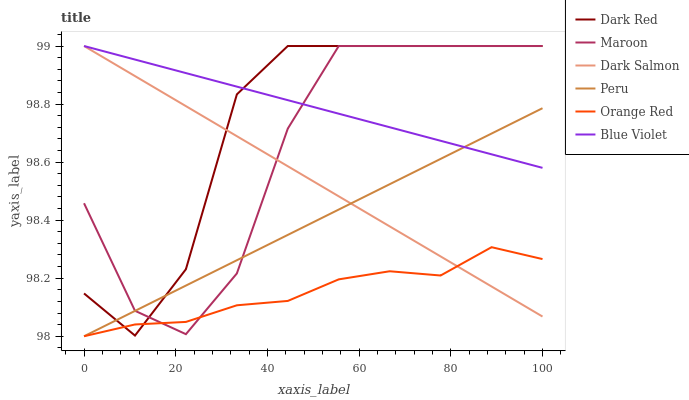Does Orange Red have the minimum area under the curve?
Answer yes or no. Yes. Does Blue Violet have the maximum area under the curve?
Answer yes or no. Yes. Does Dark Salmon have the minimum area under the curve?
Answer yes or no. No. Does Dark Salmon have the maximum area under the curve?
Answer yes or no. No. Is Dark Salmon the smoothest?
Answer yes or no. Yes. Is Maroon the roughest?
Answer yes or no. Yes. Is Maroon the smoothest?
Answer yes or no. No. Is Dark Salmon the roughest?
Answer yes or no. No. Does Peru have the lowest value?
Answer yes or no. Yes. Does Dark Salmon have the lowest value?
Answer yes or no. No. Does Blue Violet have the highest value?
Answer yes or no. Yes. Does Peru have the highest value?
Answer yes or no. No. Is Orange Red less than Blue Violet?
Answer yes or no. Yes. Is Blue Violet greater than Orange Red?
Answer yes or no. Yes. Does Orange Red intersect Peru?
Answer yes or no. Yes. Is Orange Red less than Peru?
Answer yes or no. No. Is Orange Red greater than Peru?
Answer yes or no. No. Does Orange Red intersect Blue Violet?
Answer yes or no. No. 